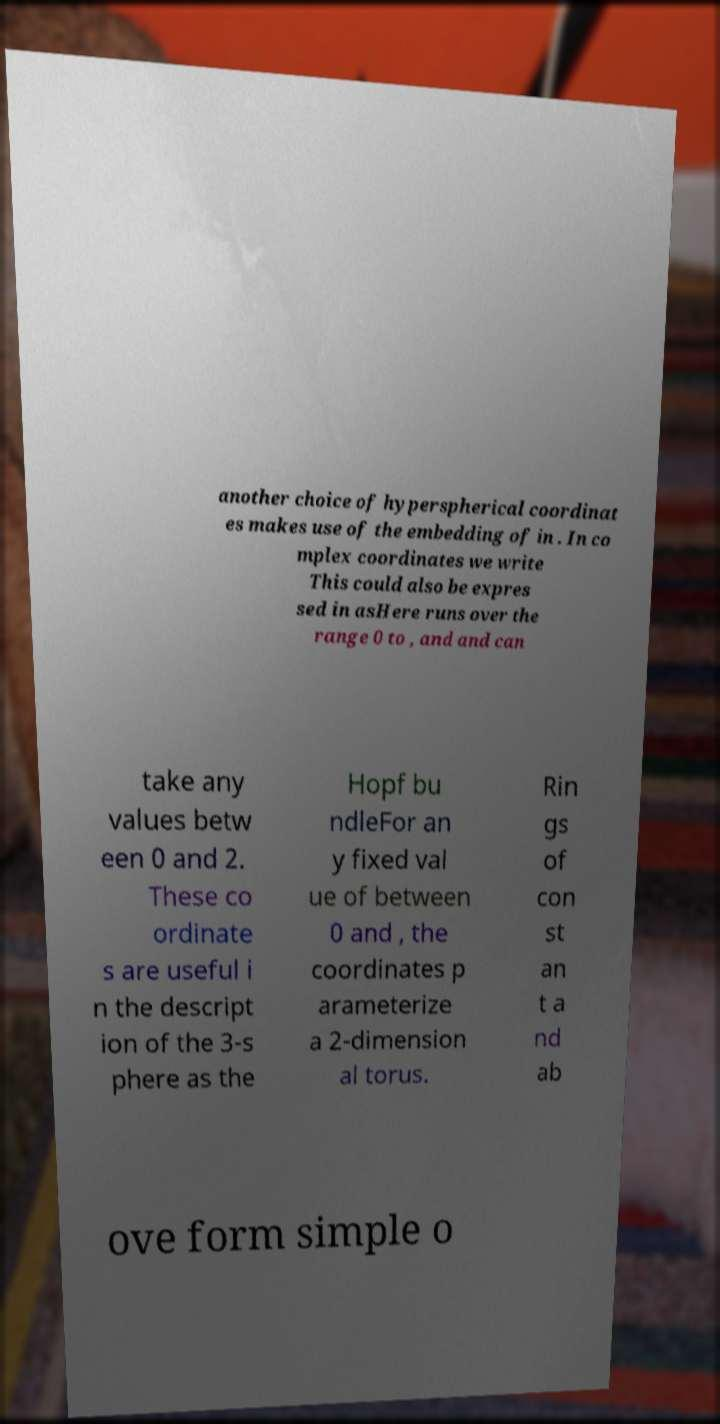There's text embedded in this image that I need extracted. Can you transcribe it verbatim? another choice of hyperspherical coordinat es makes use of the embedding of in . In co mplex coordinates we write This could also be expres sed in asHere runs over the range 0 to , and and can take any values betw een 0 and 2. These co ordinate s are useful i n the descript ion of the 3-s phere as the Hopf bu ndleFor an y fixed val ue of between 0 and , the coordinates p arameterize a 2-dimension al torus. Rin gs of con st an t a nd ab ove form simple o 